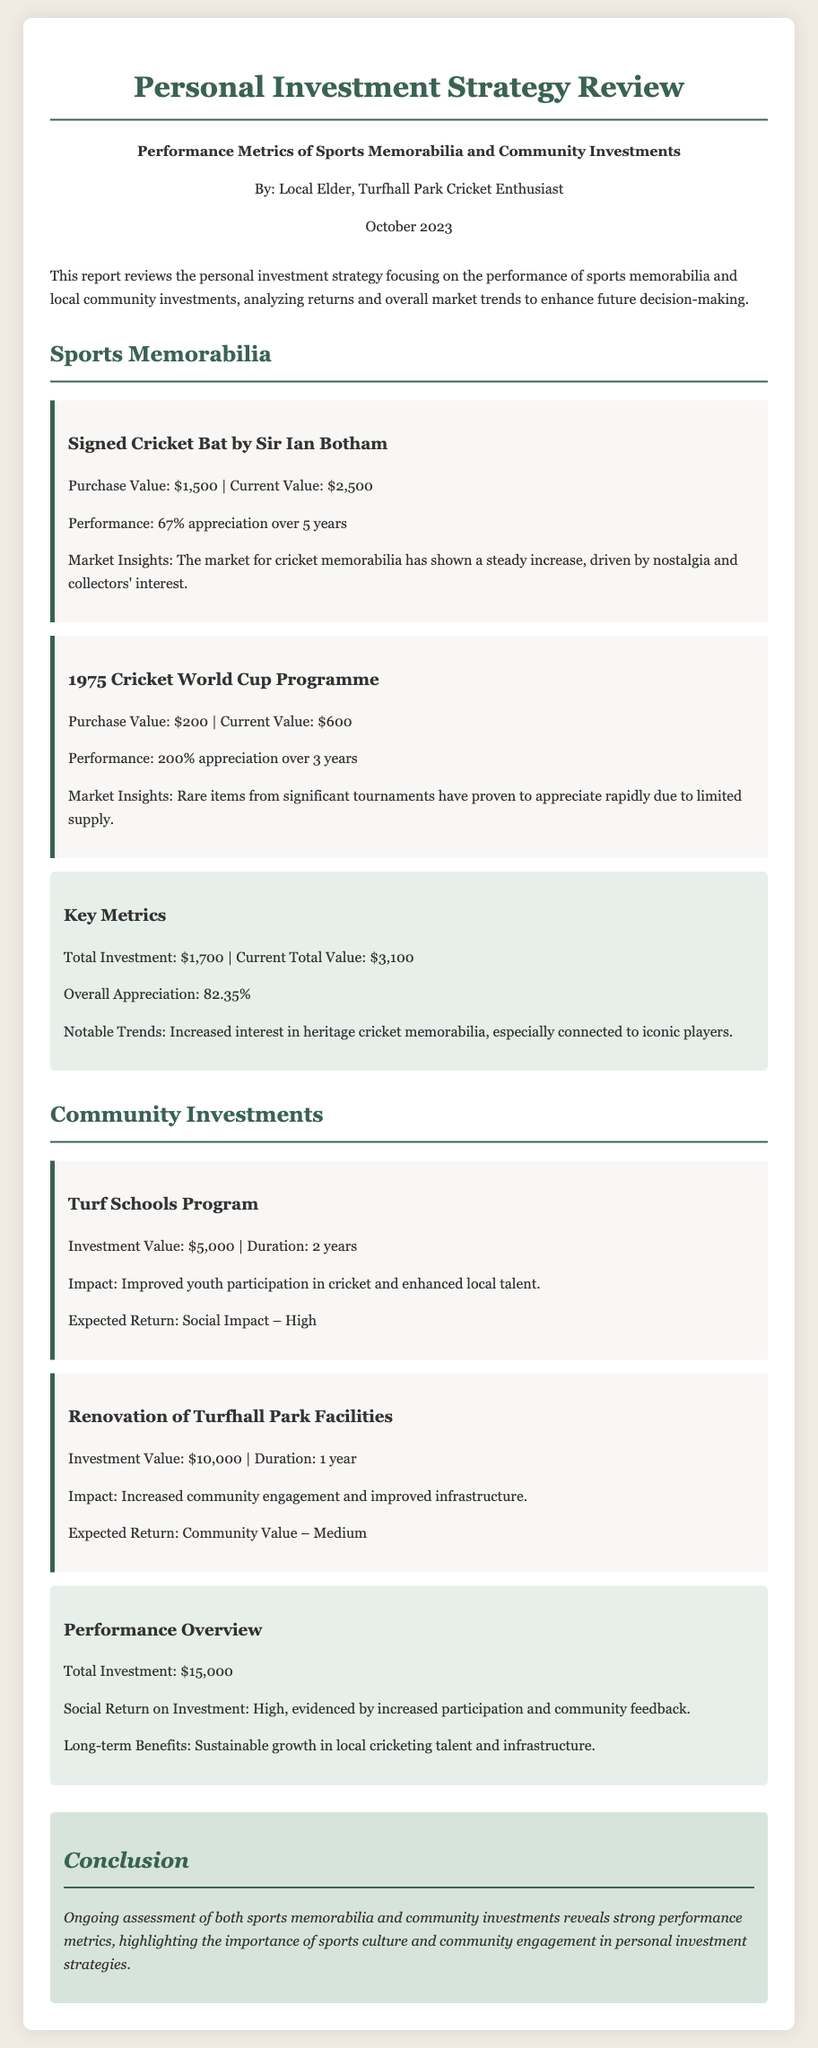What is the current value of the signed cricket bat? The current value of the signed cricket bat by Sir Ian Botham is mentioned in the document as $2,500.
Answer: $2,500 What is the overall appreciation of sports memorabilia investments? The overall appreciation is given as a percentage in the metrics section for sports memorabilia, which is 82.35%.
Answer: 82.35% What is the investment value for the Turf Schools Program? The investment value for the Turf Schools Program is specified in the document as $5,000.
Answer: $5,000 How many years did the renovation of Turfhall Park Facilities take? The duration of the renovation project is mentioned in the document as 1 year.
Answer: 1 year What is the expected return of the Turf Schools Program? The expected return is expressed qualitatively in the document as "High".
Answer: High What is the purchase value of the 1975 Cricket World Cup Programme? The purchase value is detailed in the asset section of the document as $200.
Answer: $200 What is the total investment amount for community investments? The total investment for community investments is stated in the performance overview section as $15,000.
Answer: $15,000 What is the social return on investment for community projects? The social return on investment is described in the document as "High".
Answer: High What is noted as a notable trend in sports memorabilia? A notable trend mentioned is increased interest in "heritage cricket memorabilia".
Answer: heritage cricket memorabilia 